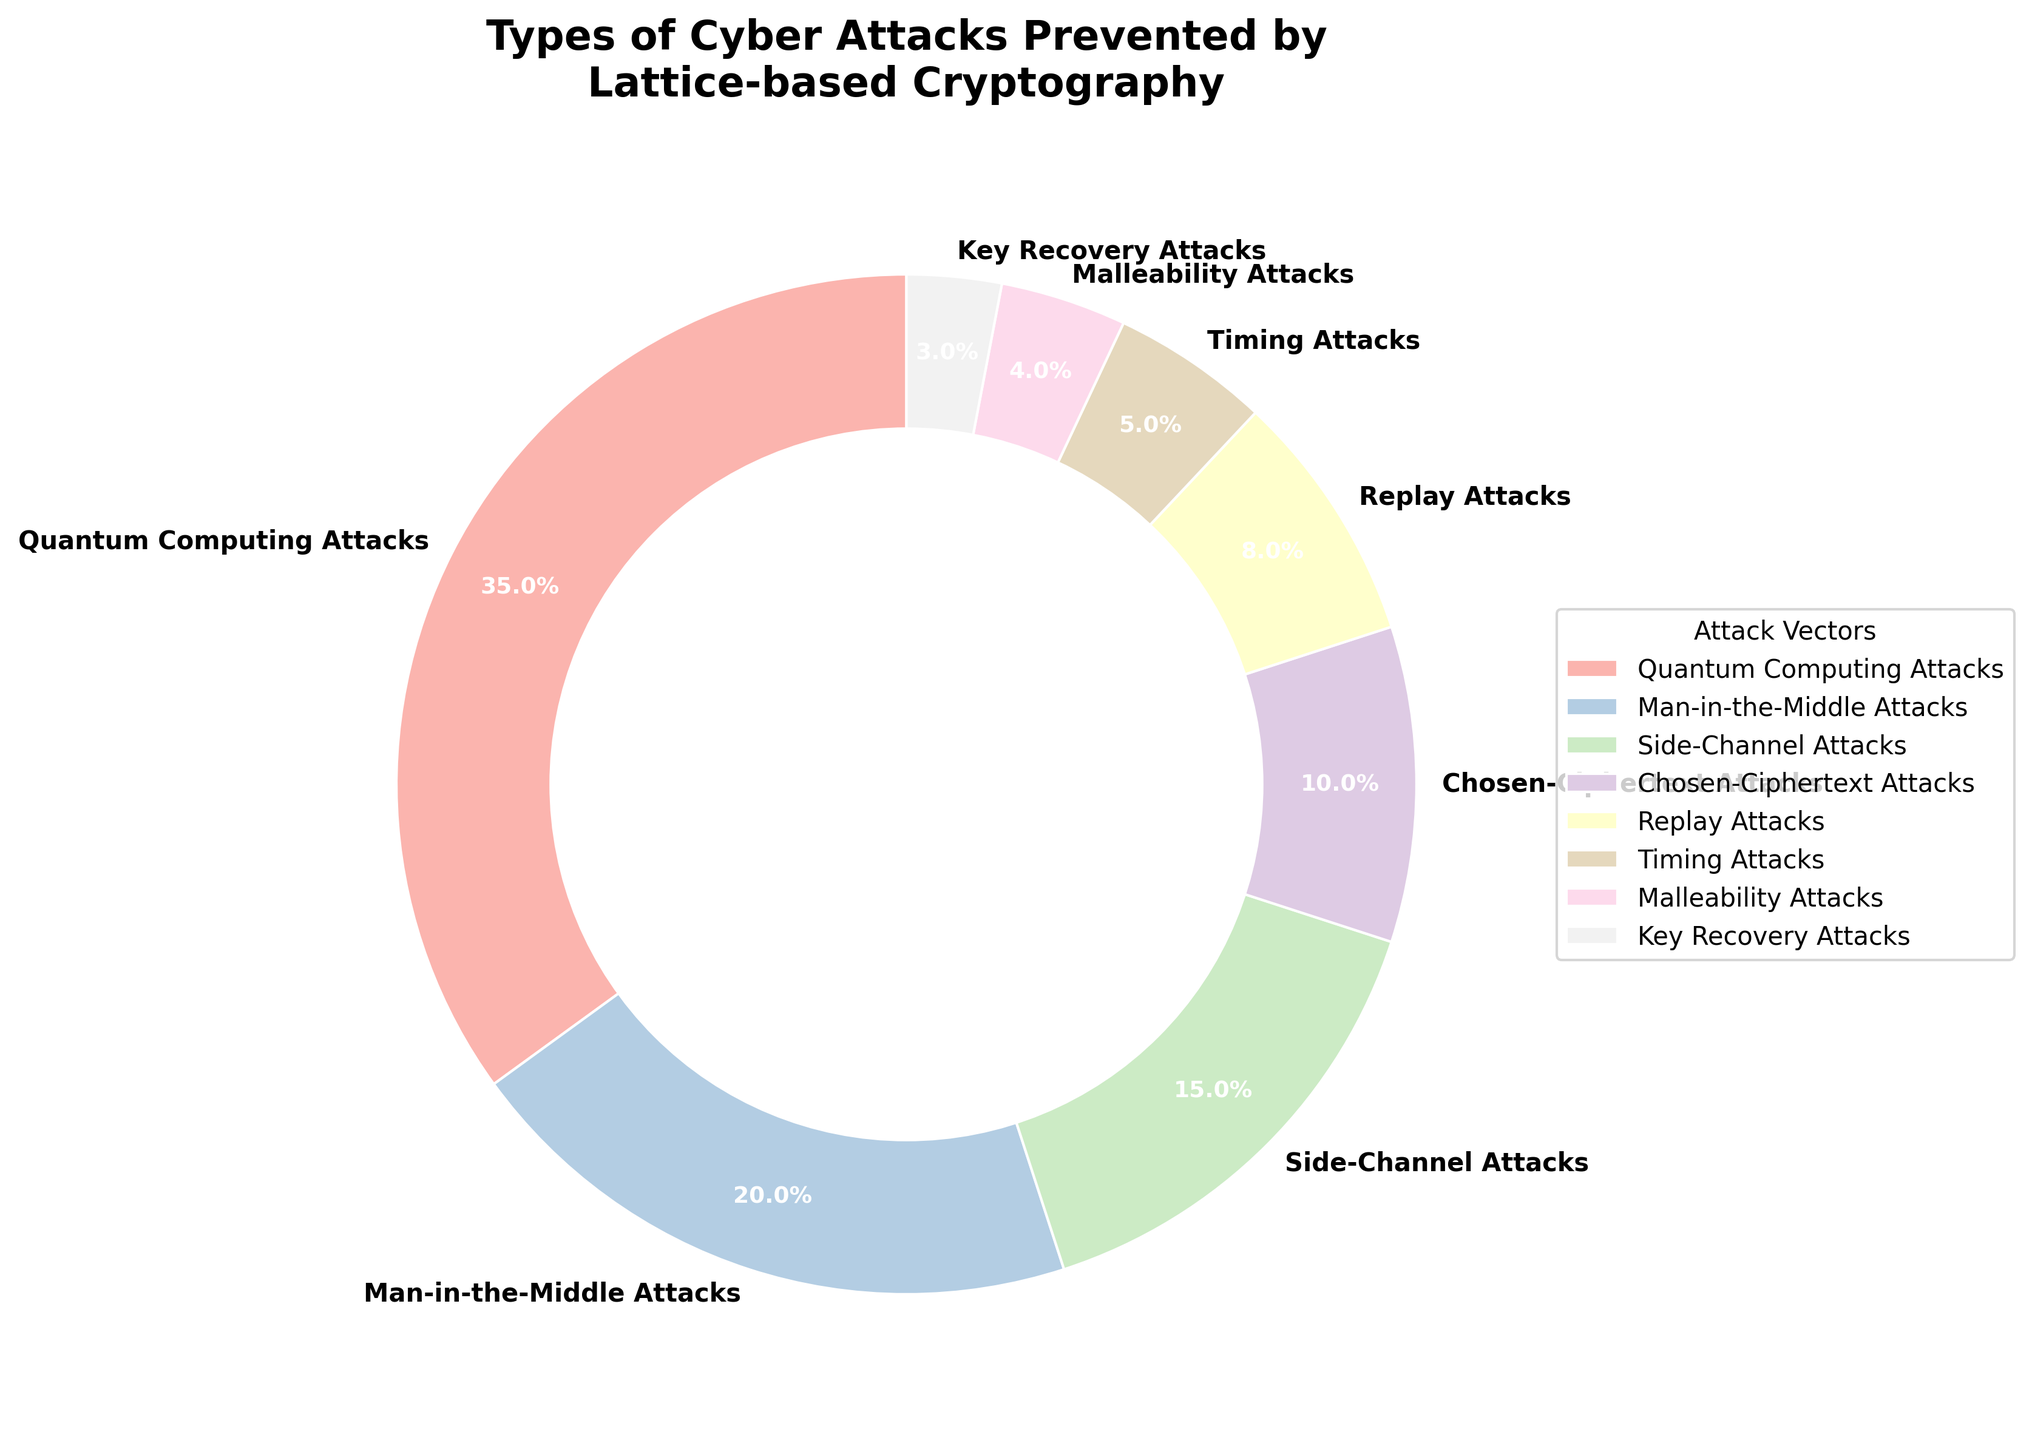Which attack vector has the highest percentage on the pie chart? The attack vector with the highest percentage can be identified by looking for the largest wedge in the pie chart. The wedge labeled "Quantum Computing Attacks" occupies the largest portion of the chart.
Answer: Quantum Computing Attacks What is the combined percentage of Side-Channel Attacks and Man-in-the-Middle Attacks? To find the combined percentage, add the percentages for Side-Channel Attacks and Man-in-the-Middle Attacks. The values are 15% and 20% respectively. So, 15% + 20% = 35%.
Answer: 35% Which has a lower percentage, Replay Attacks or Timing Attacks? Compare the percentages of Replay Attacks and Timing Attacks. Replay Attacks have 8% and Timing Attacks have 5%. Since 5% is less than 8%, Timing Attacks have the lower percentage.
Answer: Timing Attacks Are there more types of attacks with less than 10% each, or more types with 10% or higher? Count the attack vectors with percentages less than 10% and those with percentages 10% or higher. Attack vectors under 10% are 5 (8%, 5%, 4%, 3%). Those 10% or higher are 3 (35%, 20%, 15%, 10%). 5 < 4, so there are more attack vectors with less than 10%.
Answer: Less than 10% What is the percentage difference between Quantum Computing Attacks and Chosen-Ciphertext Attacks? The percentage for Quantum Computing Attacks is 35% and for Chosen-Ciphertext Attacks is 10%. Subtract the smaller percentage from the larger one: 35% - 10% = 25%.
Answer: 25% How many attack vectors contribute a single-digit percentage? Identify the attack vectors with percentages less than 10%. These are Replay Attacks (8%), Timing Attacks (5%), Malleability Attacks (4%), and Key Recovery Attacks (3%). There are 4 such attack vectors.
Answer: 4 Which attack vectors have a combined percentage equal to Quantum Computing Attacks? Quantum Computing Attacks have 35%. Looking to match this: Man-in-the-Middle Attacks (20%) + Side-Channel Attacks (15%) = 35%.
Answer: Man-in-the-Middle Attacks and Side-Channel Attacks What is the visual appearance (color) of the wedge representing Replay Attacks? Refer to the pie chart to identify the visual characteristics. The wedge representing Replay Attacks should be colored using one of the pastel colors specified in the gradient palette in the chart. This requires observation of the exact color matching from the chart.
Answer: Pastel color (exact color depends on observation) How many attack vectors have percentages greater than or equal to 15%? Count the attack vectors with percentages >= 15%. These are Quantum Computing Attacks (35%), Man-in-the-Middle Attacks (20%), and Side-Channel Attacks (15%). There are 3 such attack vectors.
Answer: 3 What is the average percentage of the attack vectors listed in the pie chart? Sum all the percentages and divide by the number of attack vectors. Total percentage = 35 + 20 + 15 + 10 + 8 + 5 + 4 + 3 = 100. Number of attack vectors = 8. Average = 100 / 8 = 12.5%.
Answer: 12.5% 